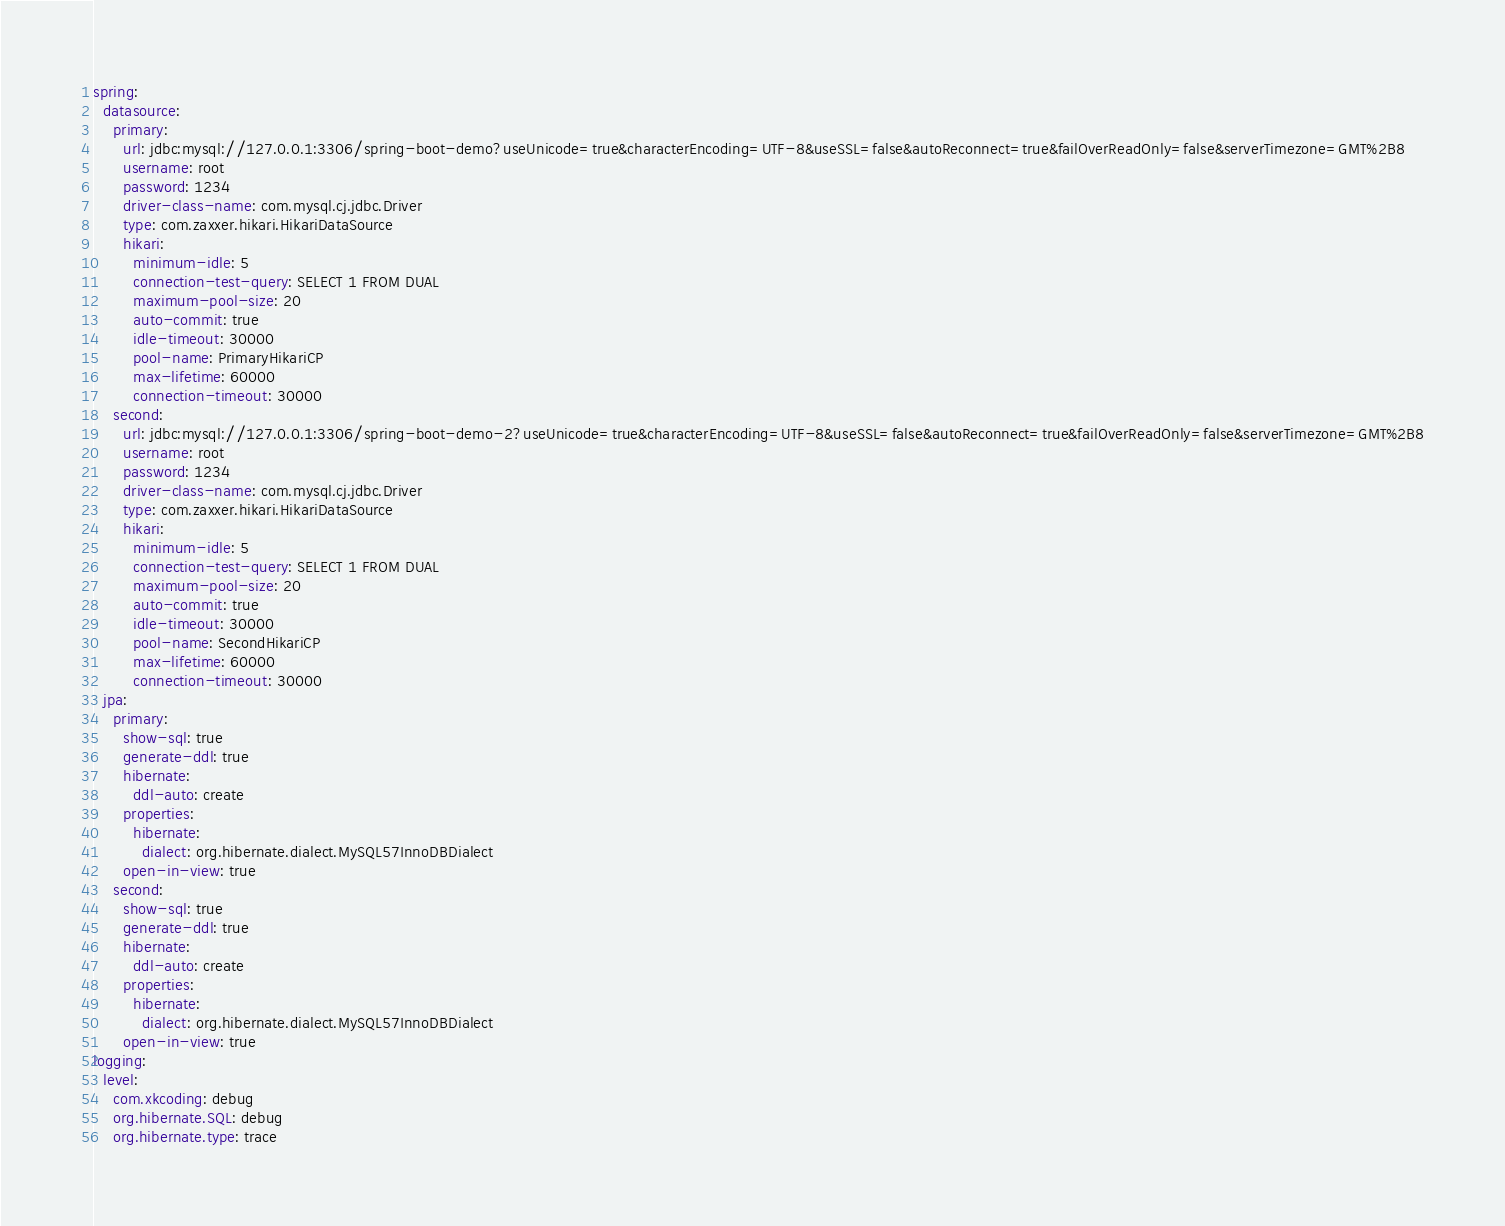<code> <loc_0><loc_0><loc_500><loc_500><_YAML_>spring:
  datasource:
    primary:
      url: jdbc:mysql://127.0.0.1:3306/spring-boot-demo?useUnicode=true&characterEncoding=UTF-8&useSSL=false&autoReconnect=true&failOverReadOnly=false&serverTimezone=GMT%2B8
      username: root
      password: 1234
      driver-class-name: com.mysql.cj.jdbc.Driver
      type: com.zaxxer.hikari.HikariDataSource
      hikari:
        minimum-idle: 5
        connection-test-query: SELECT 1 FROM DUAL
        maximum-pool-size: 20
        auto-commit: true
        idle-timeout: 30000
        pool-name: PrimaryHikariCP
        max-lifetime: 60000
        connection-timeout: 30000
    second:
      url: jdbc:mysql://127.0.0.1:3306/spring-boot-demo-2?useUnicode=true&characterEncoding=UTF-8&useSSL=false&autoReconnect=true&failOverReadOnly=false&serverTimezone=GMT%2B8
      username: root
      password: 1234
      driver-class-name: com.mysql.cj.jdbc.Driver
      type: com.zaxxer.hikari.HikariDataSource
      hikari:
        minimum-idle: 5
        connection-test-query: SELECT 1 FROM DUAL
        maximum-pool-size: 20
        auto-commit: true
        idle-timeout: 30000
        pool-name: SecondHikariCP
        max-lifetime: 60000
        connection-timeout: 30000
  jpa:
    primary:
      show-sql: true
      generate-ddl: true
      hibernate:
        ddl-auto: create
      properties:
        hibernate:
          dialect: org.hibernate.dialect.MySQL57InnoDBDialect
      open-in-view: true
    second:
      show-sql: true
      generate-ddl: true
      hibernate:
        ddl-auto: create
      properties:
        hibernate:
          dialect: org.hibernate.dialect.MySQL57InnoDBDialect
      open-in-view: true
logging:
  level:
    com.xkcoding: debug
    org.hibernate.SQL: debug
    org.hibernate.type: trace
</code> 